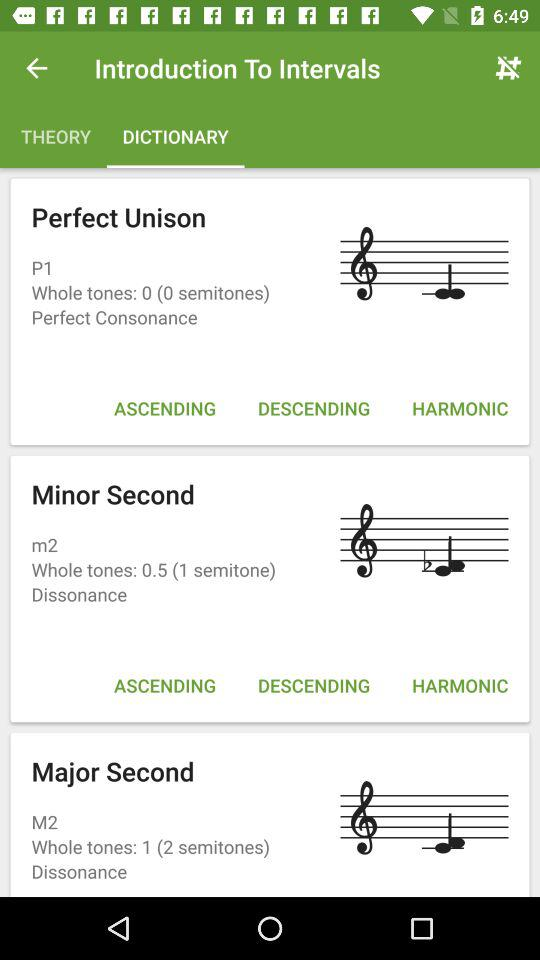How many perfect consonances are there?
Answer the question using a single word or phrase. 1 